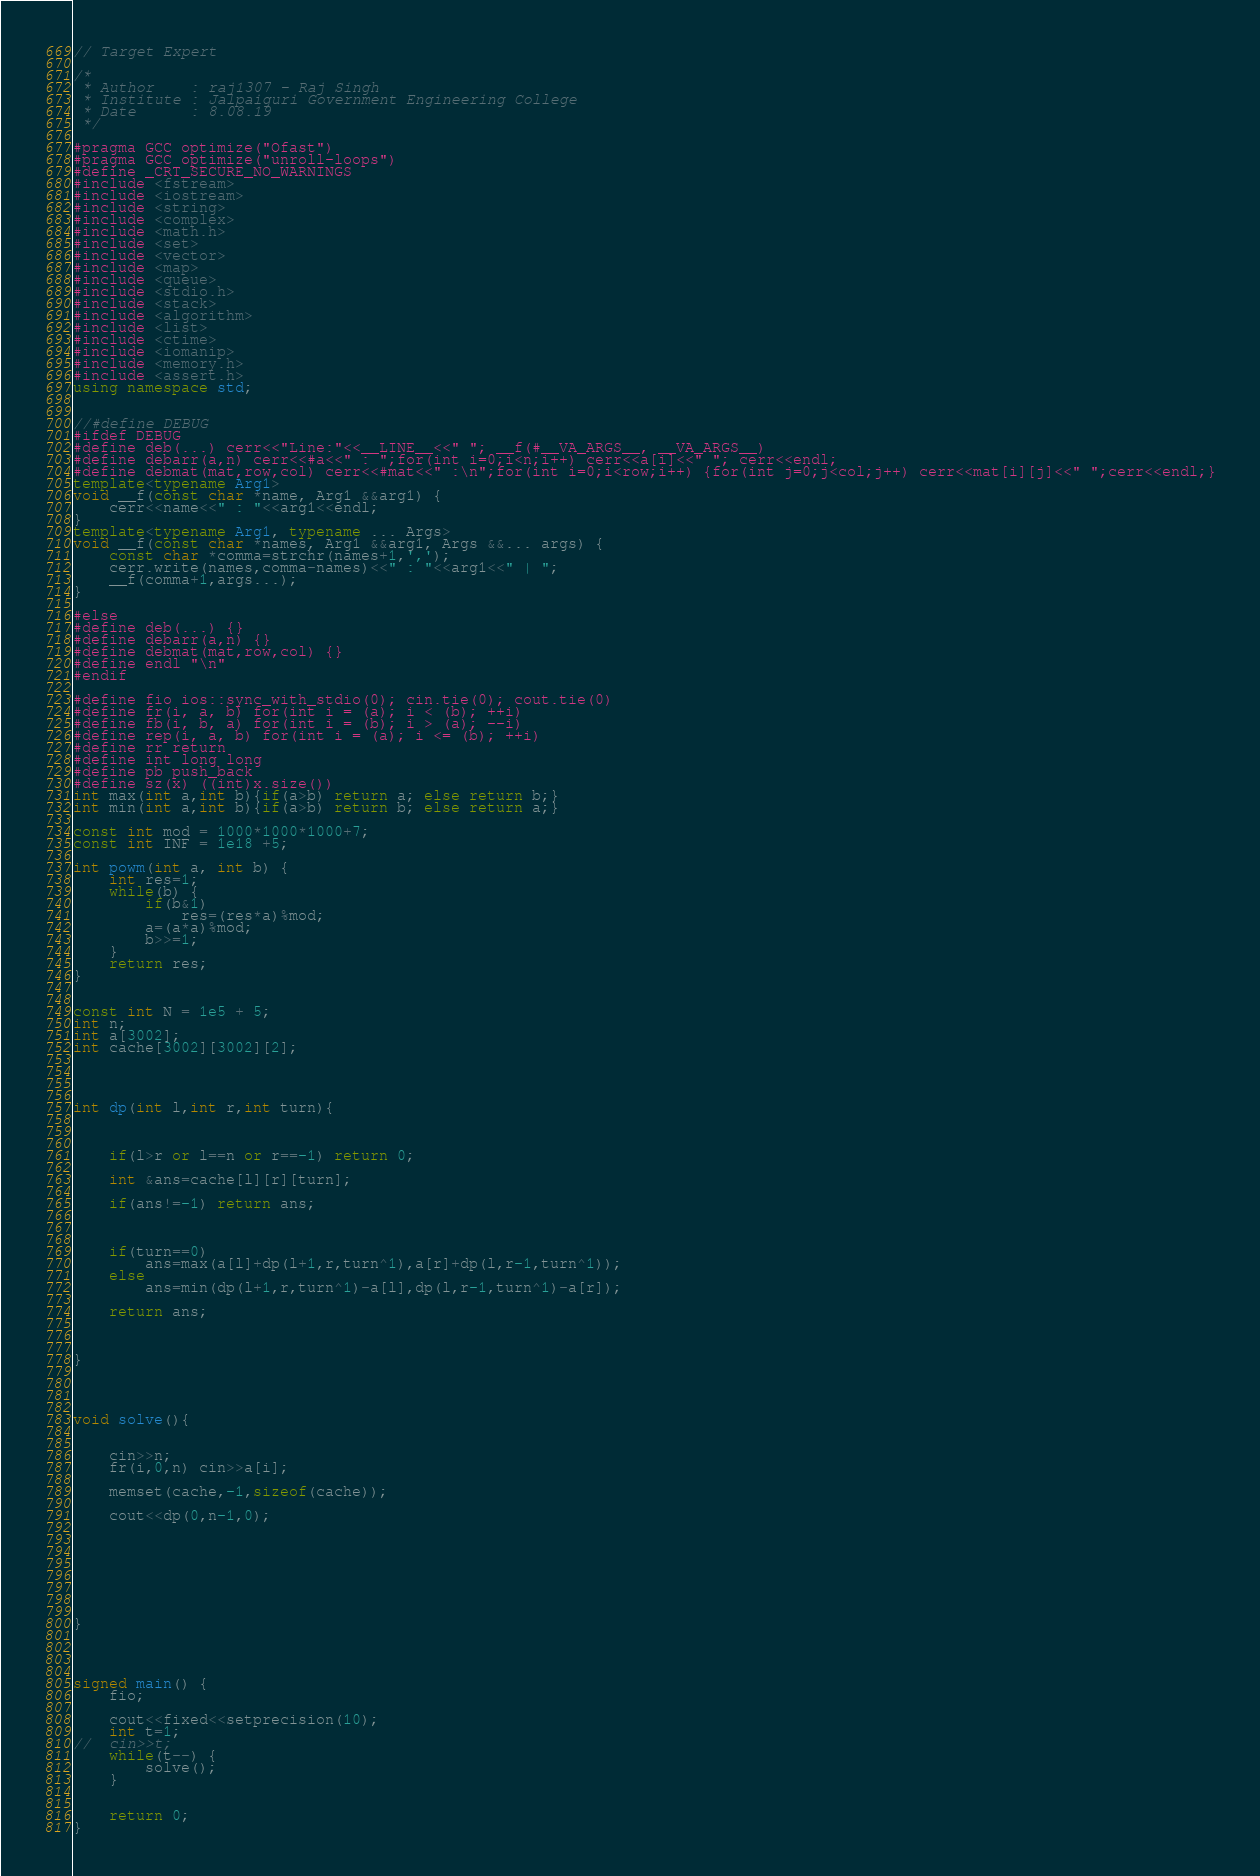Convert code to text. <code><loc_0><loc_0><loc_500><loc_500><_C++_>
// Target Expert 

/*
 * Author    : raj1307 - Raj Singh
 * Institute : Jalpaiguri Government Engineering College
 * Date      : 8.08.19
 */

#pragma GCC optimize("Ofast")
#pragma GCC optimize("unroll-loops")
#define _CRT_SECURE_NO_WARNINGS
#include <fstream>
#include <iostream>
#include <string>
#include <complex>
#include <math.h>
#include <set>
#include <vector>
#include <map>
#include <queue>
#include <stdio.h>
#include <stack>
#include <algorithm>
#include <list>
#include <ctime>
#include <iomanip>
#include <memory.h>
#include <assert.h>
using namespace std;


//#define DEBUG
#ifdef DEBUG
#define deb(...) cerr<<"Line:"<<__LINE__<<" "; __f(#__VA_ARGS__, __VA_ARGS__)
#define debarr(a,n) cerr<<#a<<" : ";for(int i=0;i<n;i++) cerr<<a[i]<<" "; cerr<<endl;
#define debmat(mat,row,col) cerr<<#mat<<" :\n";for(int i=0;i<row;i++) {for(int j=0;j<col;j++) cerr<<mat[i][j]<<" ";cerr<<endl;}
template<typename Arg1>
void __f(const char *name, Arg1 &&arg1) {
	cerr<<name<<" : "<<arg1<<endl;
}
template<typename Arg1, typename ... Args>
void __f(const char *names, Arg1 &&arg1, Args &&... args) {
	const char *comma=strchr(names+1,',');
	cerr.write(names,comma-names)<<" : "<<arg1<<" | ";
	__f(comma+1,args...);
}

#else
#define deb(...) {}
#define debarr(a,n) {}
#define debmat(mat,row,col) {}
#define endl "\n"
#endif

#define fio ios::sync_with_stdio(0); cin.tie(0); cout.tie(0)
#define fr(i, a, b) for(int i = (a); i < (b); ++i)
#define fb(i, b, a) for(int i = (b); i > (a); --i)
#define rep(i, a, b) for(int i = (a); i <= (b); ++i)
#define rr return 
#define int long long
#define pb push_back
#define sz(x) ((int)x.size())
int max(int a,int b){if(a>b) return a; else return b;}
int min(int a,int b){if(a>b) return b; else return a;}

const int mod = 1000*1000*1000+7;
const int INF = 1e18 +5;

int powm(int a, int b) {
	int res=1;
	while(b) {
		if(b&1)
			res=(res*a)%mod;
		a=(a*a)%mod;
		b>>=1;
	}
	return res;
}


const int N = 1e5 + 5;
int n;
int a[3002];
int cache[3002][3002][2];

 


int dp(int l,int r,int turn){


 
	if(l>r or l==n or r==-1) return 0;

	int &ans=cache[l][r][turn];

	if(ans!=-1) return ans;



	if(turn==0)
		ans=max(a[l]+dp(l+1,r,turn^1),a[r]+dp(l,r-1,turn^1));
	else
		ans=min(dp(l+1,r,turn^1)-a[l],dp(l,r-1,turn^1)-a[r]);

	return ans;



}



 
void solve(){
 
 
	cin>>n;
	fr(i,0,n) cin>>a[i];

	memset(cache,-1,sizeof(cache));

	cout<<dp(0,n-1,0);




	
	

 
}
 



signed main() {
	fio;

	cout<<fixed<<setprecision(10);
	int t=1;
//	cin>>t;
	while(t--) {
		solve();
	}

	
	return 0;
}
</code> 